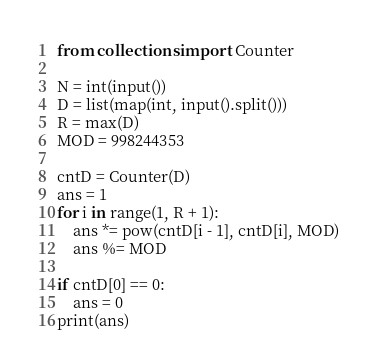<code> <loc_0><loc_0><loc_500><loc_500><_Python_>from collections import Counter

N = int(input())
D = list(map(int, input().split()))
R = max(D)
MOD = 998244353

cntD = Counter(D)
ans = 1
for i in range(1, R + 1):
    ans *= pow(cntD[i - 1], cntD[i], MOD)
    ans %= MOD

if cntD[0] == 0:
    ans = 0
print(ans)</code> 